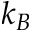<formula> <loc_0><loc_0><loc_500><loc_500>k _ { B }</formula> 